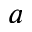<formula> <loc_0><loc_0><loc_500><loc_500>a</formula> 